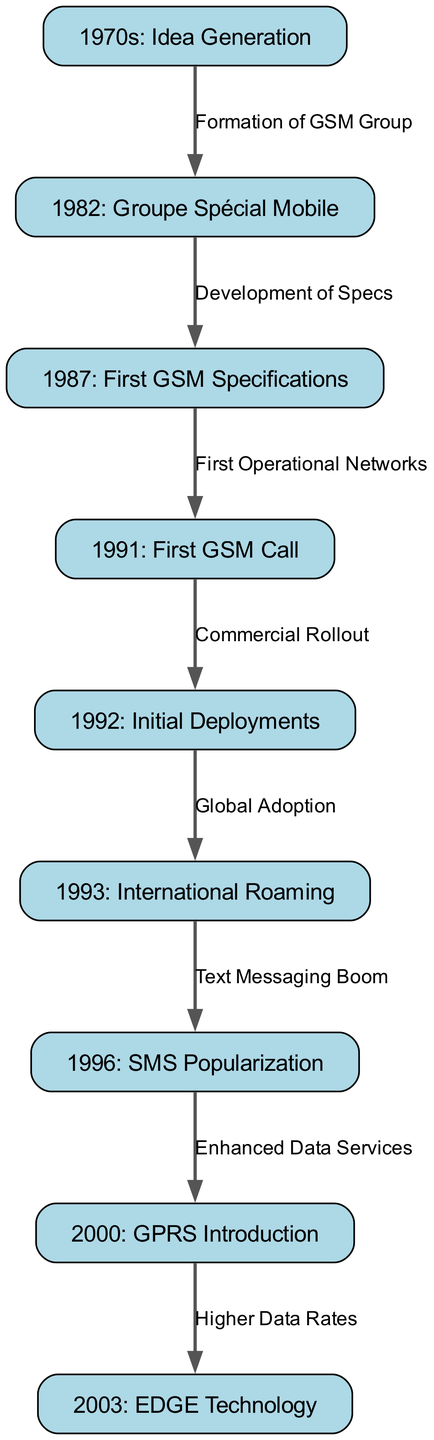What year was Groupe Spécial Mobile formed? According to the diagram, the formation of Groupe Spécial Mobile occurred in the year 1982. This is indicated directly in the node labeled "1982: Groupe Spécial Mobile."
Answer: 1982 What milestone is associated with the year 1991? The diagram shows that the milestone for the year 1991 is "First GSM Call." This is directly stated in the node for that year.
Answer: First GSM Call How many nodes are present in the diagram? To find the number of nodes, we can count all the nodes listed in the diagram. There are 9 nodes in total representing different milestones of GSM technology development.
Answer: 9 What is the label of the edge that connects nodes for "First GSM Specifications" and "First GSM Call"? In the diagram, the edge between these two nodes is labeled "First Operational Networks,” which describes the connection and the progression from specifications to the actual call happening.
Answer: First Operational Networks Which milestone directly follows "SMS Popularization" in the timeline? The diagram indicates that the milestone that follows "SMS Popularization" (1996) is "GPRS Introduction" (2000). This shows the sequence of technology evolution in GSM progression.
Answer: GPRS Introduction What development occurred in 2003 after the introduction of GPRS? According to the diagram, the milestone that follows the GPRS introduction in 2003 is "EDGE Technology," indicating the development of higher performance data services.
Answer: EDGE Technology What does the edge between "Initial Deployments" and "International Roaming" signify? The edge signifies "Global Adoption," indicating that once initial deployments took place, international roaming became a possibility, highlighting the expansion and adoption of GSM technology on a global scale.
Answer: Global Adoption What is the relationship between "Enhanced Data Services" and "Higher Data Rates"? The diagram demonstrates that "Higher Data Rates" (2003) is the result of "Enhanced Data Services" (2000), conveying that improvements in data services led to better overall data rates.
Answer: Higher Data Rates Which node marks the beginning of the GSM timeline? The beginning of the GSM timeline is marked by the node "1970s: Idea Generation," which indicates the inception of the idea that eventually led to GSM technology development.
Answer: 1970s: Idea Generation 